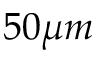<formula> <loc_0><loc_0><loc_500><loc_500>5 0 \mu m</formula> 